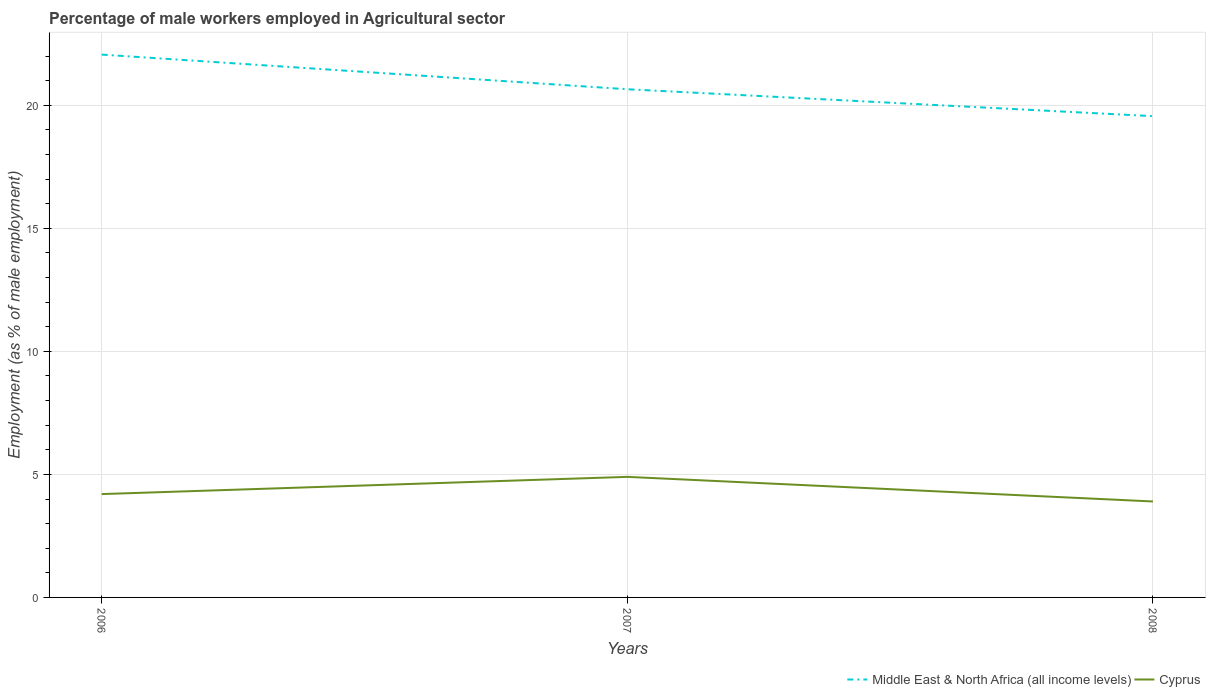How many different coloured lines are there?
Provide a succinct answer. 2. Is the number of lines equal to the number of legend labels?
Make the answer very short. Yes. Across all years, what is the maximum percentage of male workers employed in Agricultural sector in Cyprus?
Provide a short and direct response. 3.9. In which year was the percentage of male workers employed in Agricultural sector in Middle East & North Africa (all income levels) maximum?
Your answer should be compact. 2008. What is the total percentage of male workers employed in Agricultural sector in Middle East & North Africa (all income levels) in the graph?
Make the answer very short. 1.41. What is the difference between the highest and the second highest percentage of male workers employed in Agricultural sector in Middle East & North Africa (all income levels)?
Provide a short and direct response. 2.5. Is the percentage of male workers employed in Agricultural sector in Middle East & North Africa (all income levels) strictly greater than the percentage of male workers employed in Agricultural sector in Cyprus over the years?
Your answer should be compact. No. How many years are there in the graph?
Ensure brevity in your answer.  3. Are the values on the major ticks of Y-axis written in scientific E-notation?
Your response must be concise. No. Does the graph contain grids?
Provide a succinct answer. Yes. Where does the legend appear in the graph?
Ensure brevity in your answer.  Bottom right. How many legend labels are there?
Give a very brief answer. 2. What is the title of the graph?
Keep it short and to the point. Percentage of male workers employed in Agricultural sector. Does "Chile" appear as one of the legend labels in the graph?
Your response must be concise. No. What is the label or title of the X-axis?
Give a very brief answer. Years. What is the label or title of the Y-axis?
Provide a succinct answer. Employment (as % of male employment). What is the Employment (as % of male employment) in Middle East & North Africa (all income levels) in 2006?
Offer a terse response. 22.06. What is the Employment (as % of male employment) of Cyprus in 2006?
Provide a succinct answer. 4.2. What is the Employment (as % of male employment) of Middle East & North Africa (all income levels) in 2007?
Ensure brevity in your answer.  20.65. What is the Employment (as % of male employment) in Cyprus in 2007?
Your answer should be compact. 4.9. What is the Employment (as % of male employment) of Middle East & North Africa (all income levels) in 2008?
Provide a short and direct response. 19.56. What is the Employment (as % of male employment) of Cyprus in 2008?
Provide a short and direct response. 3.9. Across all years, what is the maximum Employment (as % of male employment) of Middle East & North Africa (all income levels)?
Provide a short and direct response. 22.06. Across all years, what is the maximum Employment (as % of male employment) in Cyprus?
Provide a succinct answer. 4.9. Across all years, what is the minimum Employment (as % of male employment) in Middle East & North Africa (all income levels)?
Ensure brevity in your answer.  19.56. Across all years, what is the minimum Employment (as % of male employment) of Cyprus?
Your answer should be compact. 3.9. What is the total Employment (as % of male employment) in Middle East & North Africa (all income levels) in the graph?
Provide a short and direct response. 62.28. What is the difference between the Employment (as % of male employment) of Middle East & North Africa (all income levels) in 2006 and that in 2007?
Your answer should be very brief. 1.41. What is the difference between the Employment (as % of male employment) of Cyprus in 2006 and that in 2007?
Give a very brief answer. -0.7. What is the difference between the Employment (as % of male employment) of Middle East & North Africa (all income levels) in 2006 and that in 2008?
Your answer should be very brief. 2.5. What is the difference between the Employment (as % of male employment) of Cyprus in 2006 and that in 2008?
Ensure brevity in your answer.  0.3. What is the difference between the Employment (as % of male employment) of Middle East & North Africa (all income levels) in 2007 and that in 2008?
Provide a short and direct response. 1.09. What is the difference between the Employment (as % of male employment) of Cyprus in 2007 and that in 2008?
Keep it short and to the point. 1. What is the difference between the Employment (as % of male employment) of Middle East & North Africa (all income levels) in 2006 and the Employment (as % of male employment) of Cyprus in 2007?
Your response must be concise. 17.16. What is the difference between the Employment (as % of male employment) in Middle East & North Africa (all income levels) in 2006 and the Employment (as % of male employment) in Cyprus in 2008?
Keep it short and to the point. 18.16. What is the difference between the Employment (as % of male employment) of Middle East & North Africa (all income levels) in 2007 and the Employment (as % of male employment) of Cyprus in 2008?
Offer a terse response. 16.75. What is the average Employment (as % of male employment) in Middle East & North Africa (all income levels) per year?
Provide a short and direct response. 20.76. What is the average Employment (as % of male employment) in Cyprus per year?
Provide a succinct answer. 4.33. In the year 2006, what is the difference between the Employment (as % of male employment) of Middle East & North Africa (all income levels) and Employment (as % of male employment) of Cyprus?
Provide a short and direct response. 17.86. In the year 2007, what is the difference between the Employment (as % of male employment) of Middle East & North Africa (all income levels) and Employment (as % of male employment) of Cyprus?
Make the answer very short. 15.75. In the year 2008, what is the difference between the Employment (as % of male employment) in Middle East & North Africa (all income levels) and Employment (as % of male employment) in Cyprus?
Your answer should be compact. 15.66. What is the ratio of the Employment (as % of male employment) in Middle East & North Africa (all income levels) in 2006 to that in 2007?
Make the answer very short. 1.07. What is the ratio of the Employment (as % of male employment) of Cyprus in 2006 to that in 2007?
Ensure brevity in your answer.  0.86. What is the ratio of the Employment (as % of male employment) of Middle East & North Africa (all income levels) in 2006 to that in 2008?
Keep it short and to the point. 1.13. What is the ratio of the Employment (as % of male employment) of Cyprus in 2006 to that in 2008?
Your answer should be compact. 1.08. What is the ratio of the Employment (as % of male employment) in Middle East & North Africa (all income levels) in 2007 to that in 2008?
Ensure brevity in your answer.  1.06. What is the ratio of the Employment (as % of male employment) in Cyprus in 2007 to that in 2008?
Offer a terse response. 1.26. What is the difference between the highest and the second highest Employment (as % of male employment) of Middle East & North Africa (all income levels)?
Offer a very short reply. 1.41. What is the difference between the highest and the second highest Employment (as % of male employment) in Cyprus?
Your response must be concise. 0.7. What is the difference between the highest and the lowest Employment (as % of male employment) of Middle East & North Africa (all income levels)?
Keep it short and to the point. 2.5. 